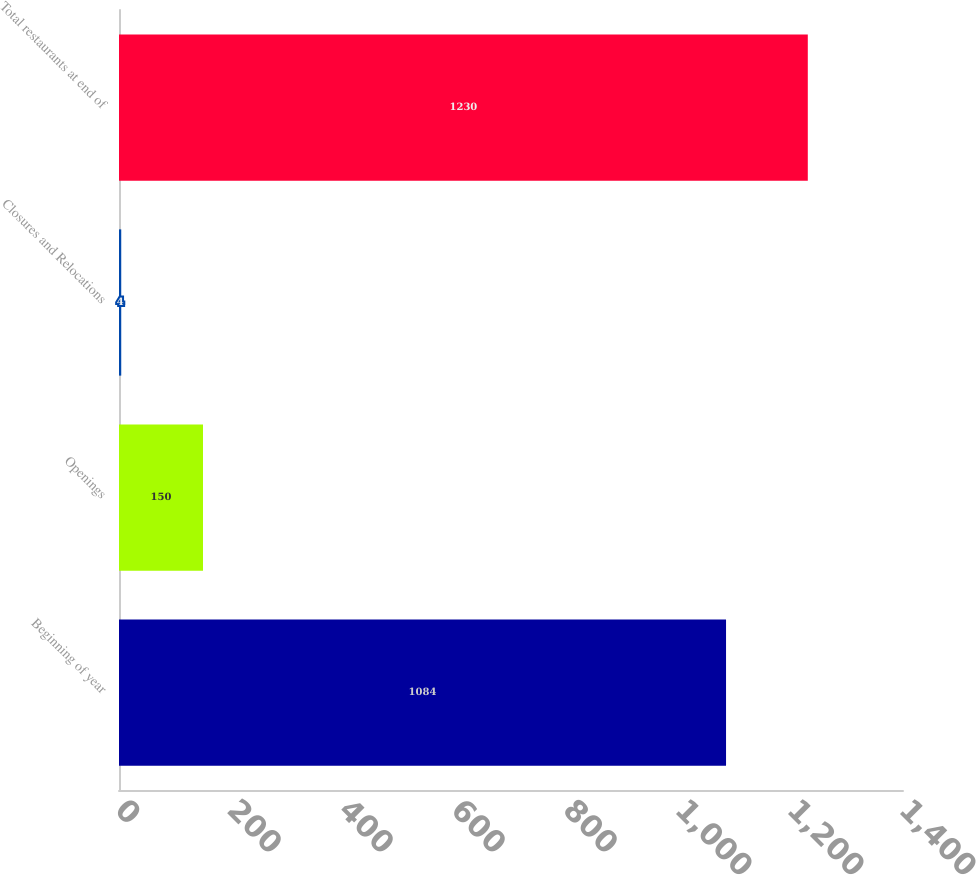Convert chart to OTSL. <chart><loc_0><loc_0><loc_500><loc_500><bar_chart><fcel>Beginning of year<fcel>Openings<fcel>Closures and Relocations<fcel>Total restaurants at end of<nl><fcel>1084<fcel>150<fcel>4<fcel>1230<nl></chart> 